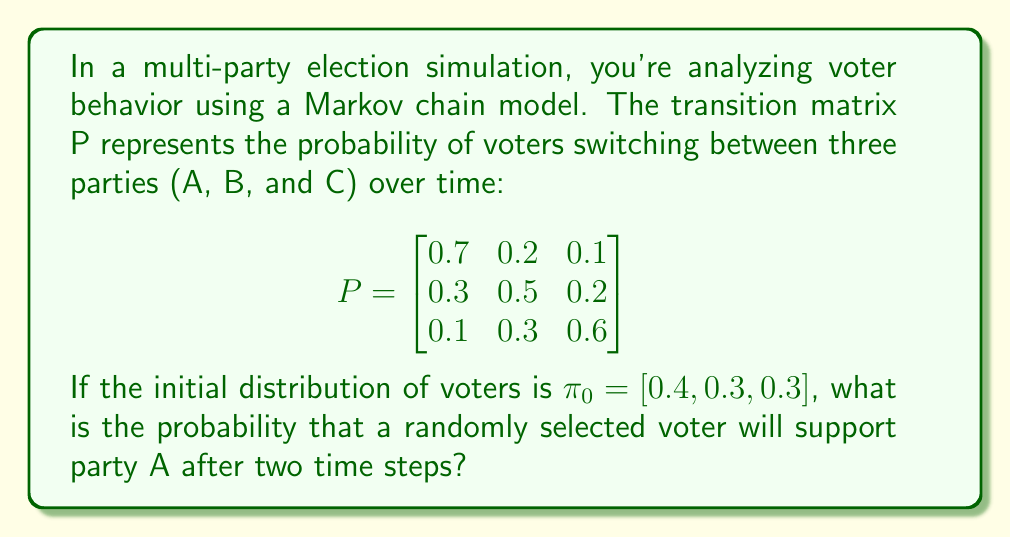Show me your answer to this math problem. To solve this problem, we need to follow these steps:

1. Understand the given information:
   - P is the transition matrix
   - $\pi_0 = [0.4, 0.3, 0.3]$ is the initial distribution of voters

2. Calculate the distribution after one time step:
   $\pi_1 = \pi_0 P$
   
   $$\pi_1 = [0.4, 0.3, 0.3] \begin{bmatrix}
   0.7 & 0.2 & 0.1 \\
   0.3 & 0.5 & 0.2 \\
   0.1 & 0.3 & 0.6
   \end{bmatrix}$$
   
   $\pi_1 = [0.4(0.7) + 0.3(0.3) + 0.3(0.1), 0.4(0.2) + 0.3(0.5) + 0.3(0.3), 0.4(0.1) + 0.3(0.2) + 0.3(0.6)]$
   
   $\pi_1 = [0.41, 0.31, 0.28]$

3. Calculate the distribution after two time steps:
   $\pi_2 = \pi_1 P$
   
   $$\pi_2 = [0.41, 0.31, 0.28] \begin{bmatrix}
   0.7 & 0.2 & 0.1 \\
   0.3 & 0.5 & 0.2 \\
   0.1 & 0.3 & 0.6
   \end{bmatrix}$$
   
   $\pi_2 = [0.41(0.7) + 0.31(0.3) + 0.28(0.1), 0.41(0.2) + 0.31(0.5) + 0.28(0.3), 0.41(0.1) + 0.31(0.2) + 0.28(0.6)]$
   
   $\pi_2 = [0.4165, 0.3125, 0.2710]$

4. The probability of supporting party A after two time steps is the first element of $\pi_2$, which is 0.4165 or approximately 0.42.
Answer: 0.42 